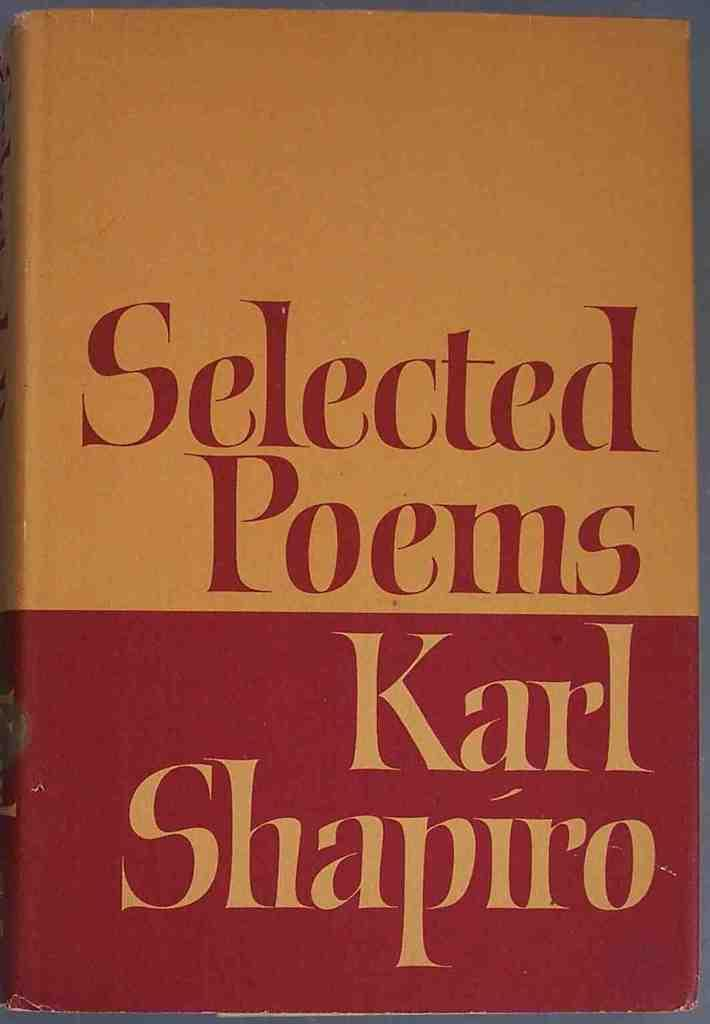<image>
Offer a succinct explanation of the picture presented. The book Selected Poems was written by Karl Shapiro. 